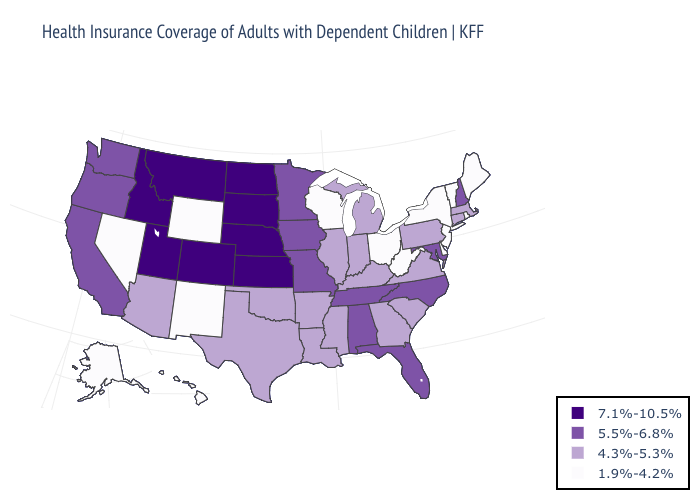Name the states that have a value in the range 1.9%-4.2%?
Be succinct. Alaska, Delaware, Hawaii, Maine, Nevada, New Jersey, New Mexico, New York, Ohio, Rhode Island, Vermont, West Virginia, Wisconsin, Wyoming. Name the states that have a value in the range 7.1%-10.5%?
Concise answer only. Colorado, Idaho, Kansas, Montana, Nebraska, North Dakota, South Dakota, Utah. Name the states that have a value in the range 5.5%-6.8%?
Write a very short answer. Alabama, California, Florida, Iowa, Maryland, Minnesota, Missouri, New Hampshire, North Carolina, Oregon, Tennessee, Washington. Among the states that border South Dakota , does Nebraska have the highest value?
Short answer required. Yes. Which states have the lowest value in the USA?
Quick response, please. Alaska, Delaware, Hawaii, Maine, Nevada, New Jersey, New Mexico, New York, Ohio, Rhode Island, Vermont, West Virginia, Wisconsin, Wyoming. What is the value of Hawaii?
Write a very short answer. 1.9%-4.2%. What is the value of North Carolina?
Answer briefly. 5.5%-6.8%. Name the states that have a value in the range 7.1%-10.5%?
Answer briefly. Colorado, Idaho, Kansas, Montana, Nebraska, North Dakota, South Dakota, Utah. What is the highest value in the Northeast ?
Be succinct. 5.5%-6.8%. Name the states that have a value in the range 1.9%-4.2%?
Write a very short answer. Alaska, Delaware, Hawaii, Maine, Nevada, New Jersey, New Mexico, New York, Ohio, Rhode Island, Vermont, West Virginia, Wisconsin, Wyoming. Does the first symbol in the legend represent the smallest category?
Answer briefly. No. Does Massachusetts have the same value as Minnesota?
Keep it brief. No. Does West Virginia have the lowest value in the USA?
Give a very brief answer. Yes. Name the states that have a value in the range 1.9%-4.2%?
Short answer required. Alaska, Delaware, Hawaii, Maine, Nevada, New Jersey, New Mexico, New York, Ohio, Rhode Island, Vermont, West Virginia, Wisconsin, Wyoming. What is the value of Louisiana?
Be succinct. 4.3%-5.3%. 